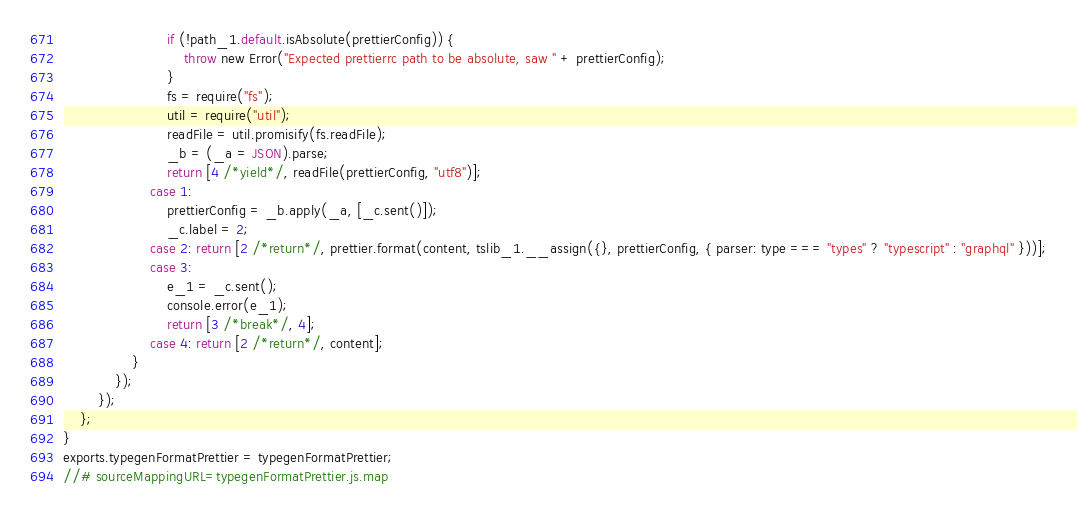Convert code to text. <code><loc_0><loc_0><loc_500><loc_500><_JavaScript_>                        if (!path_1.default.isAbsolute(prettierConfig)) {
                            throw new Error("Expected prettierrc path to be absolute, saw " + prettierConfig);
                        }
                        fs = require("fs");
                        util = require("util");
                        readFile = util.promisify(fs.readFile);
                        _b = (_a = JSON).parse;
                        return [4 /*yield*/, readFile(prettierConfig, "utf8")];
                    case 1:
                        prettierConfig = _b.apply(_a, [_c.sent()]);
                        _c.label = 2;
                    case 2: return [2 /*return*/, prettier.format(content, tslib_1.__assign({}, prettierConfig, { parser: type === "types" ? "typescript" : "graphql" }))];
                    case 3:
                        e_1 = _c.sent();
                        console.error(e_1);
                        return [3 /*break*/, 4];
                    case 4: return [2 /*return*/, content];
                }
            });
        });
    };
}
exports.typegenFormatPrettier = typegenFormatPrettier;
//# sourceMappingURL=typegenFormatPrettier.js.map</code> 